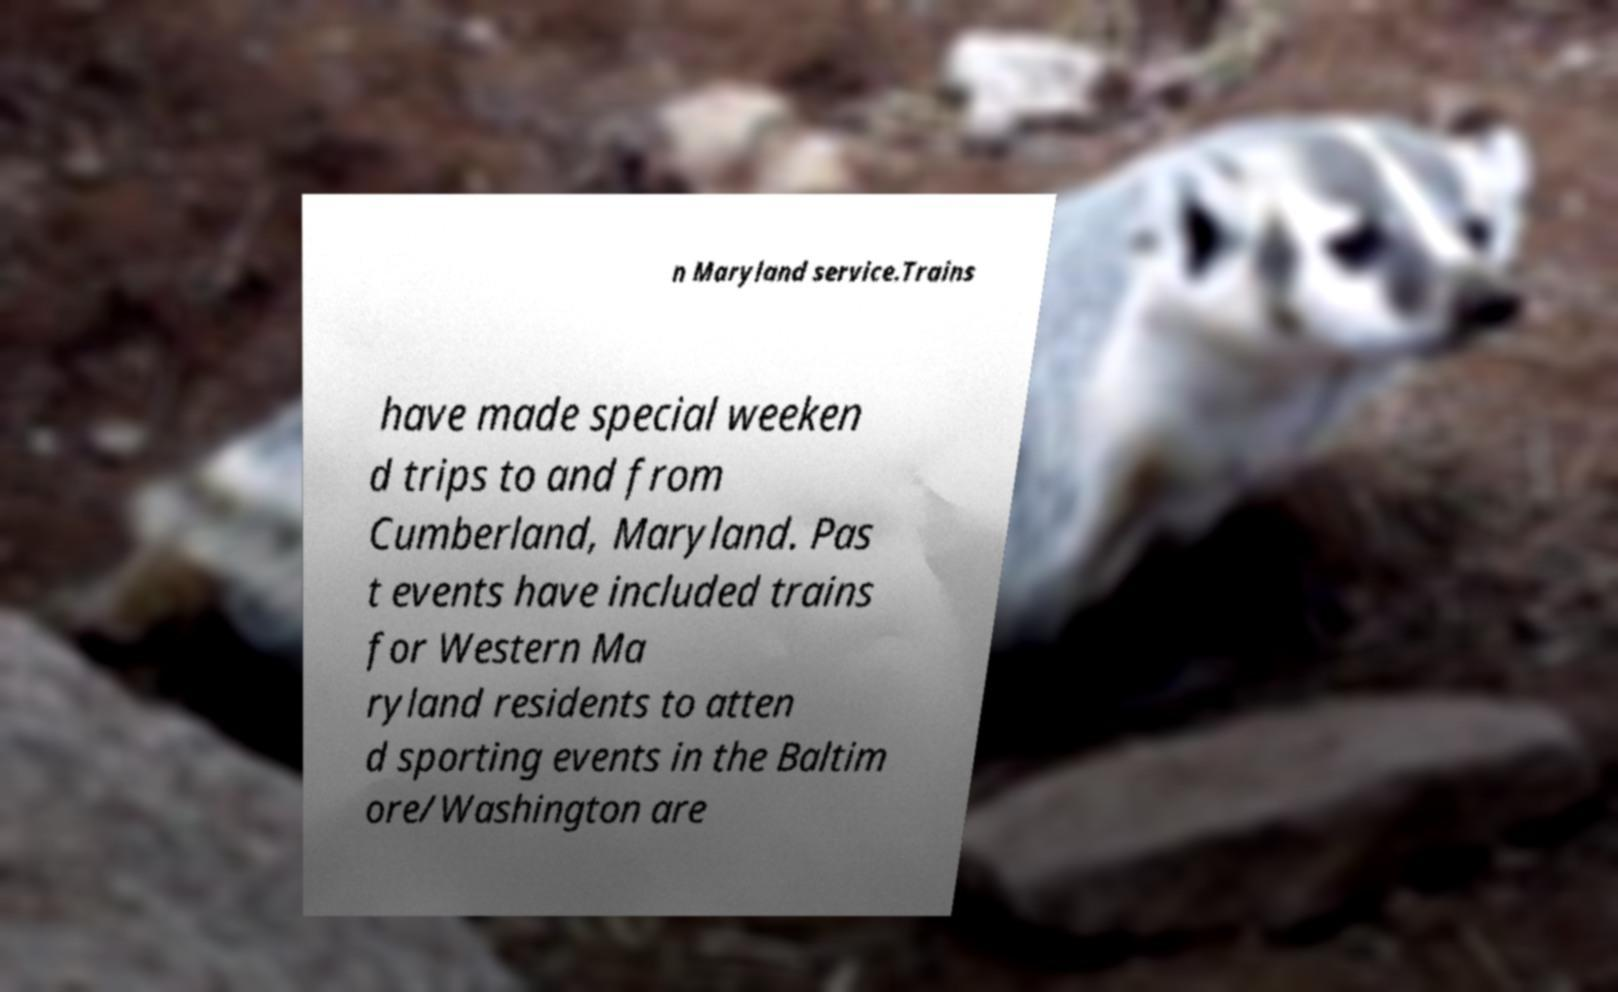Could you assist in decoding the text presented in this image and type it out clearly? n Maryland service.Trains have made special weeken d trips to and from Cumberland, Maryland. Pas t events have included trains for Western Ma ryland residents to atten d sporting events in the Baltim ore/Washington are 